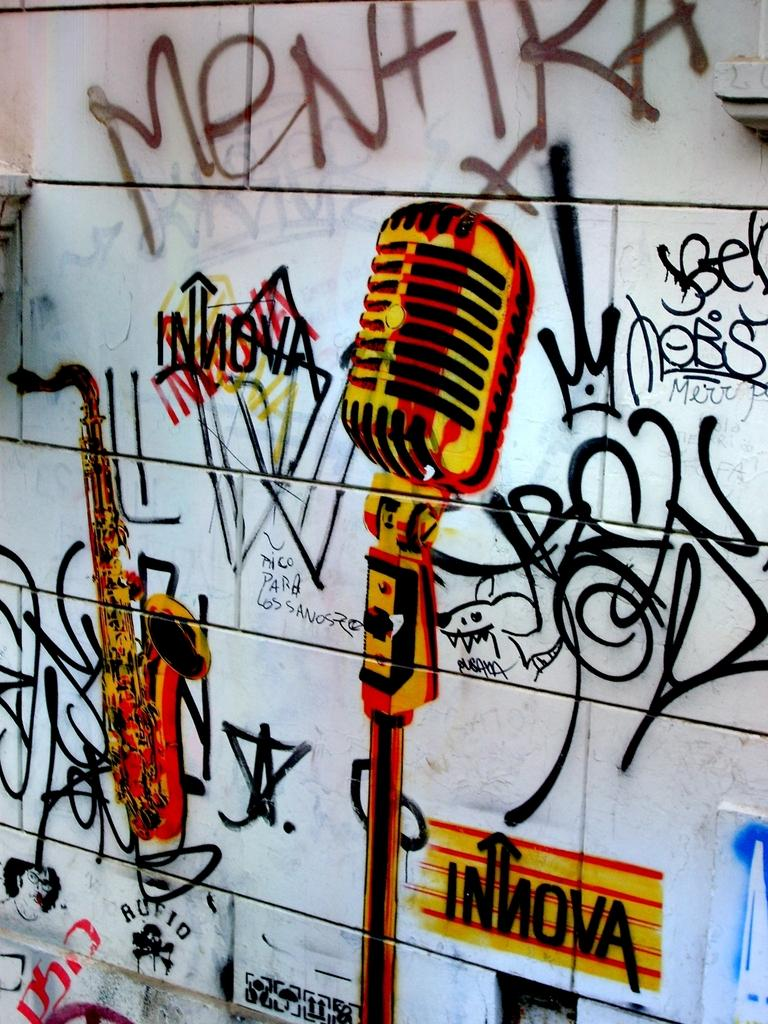What is present on the wall in the image? There is a painting on the wall in the image. What elements are included in the painting? The painting includes a microphone, a musical instrument, and other designs. What type of corn is depicted in the painting? There is no corn present in the painting; it includes a microphone, a musical instrument, and other designs. 